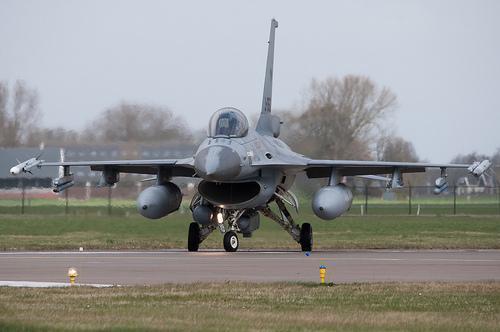How many jets are there?
Give a very brief answer. 1. 